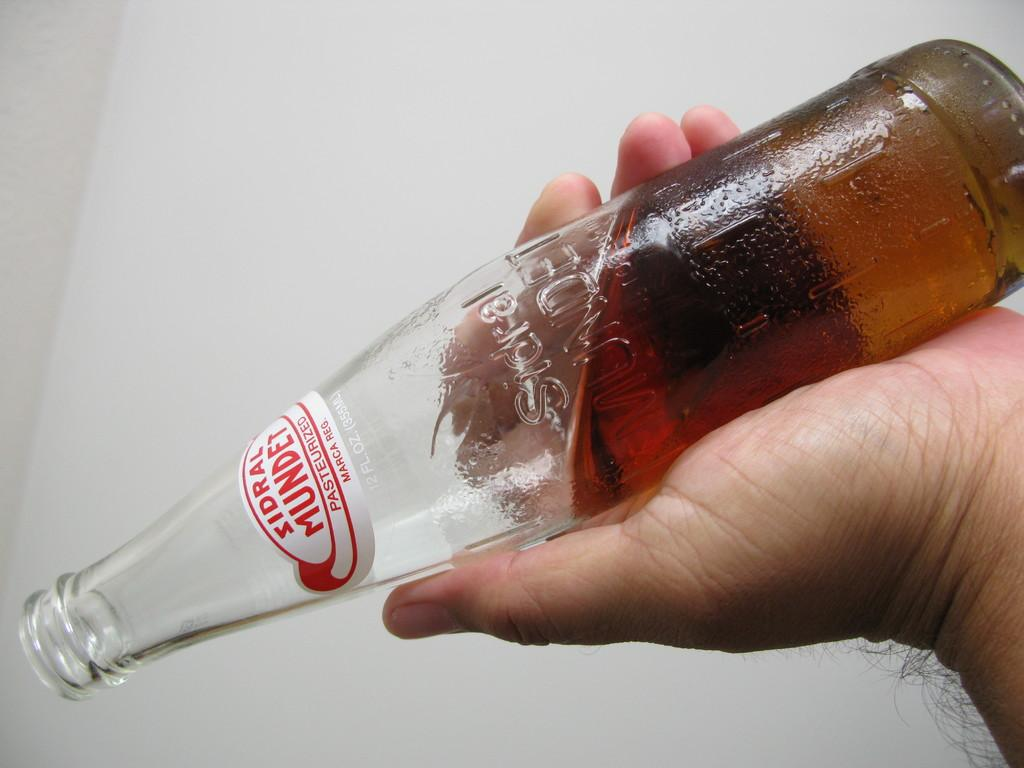What object can be seen in the image? There is a bottle in the image. Can you describe any other elements in the image? A human hand is visible in the image. How many cars are parked next to the bottle in the image? There are no cars present in the image; it only features a bottle and a human hand. 